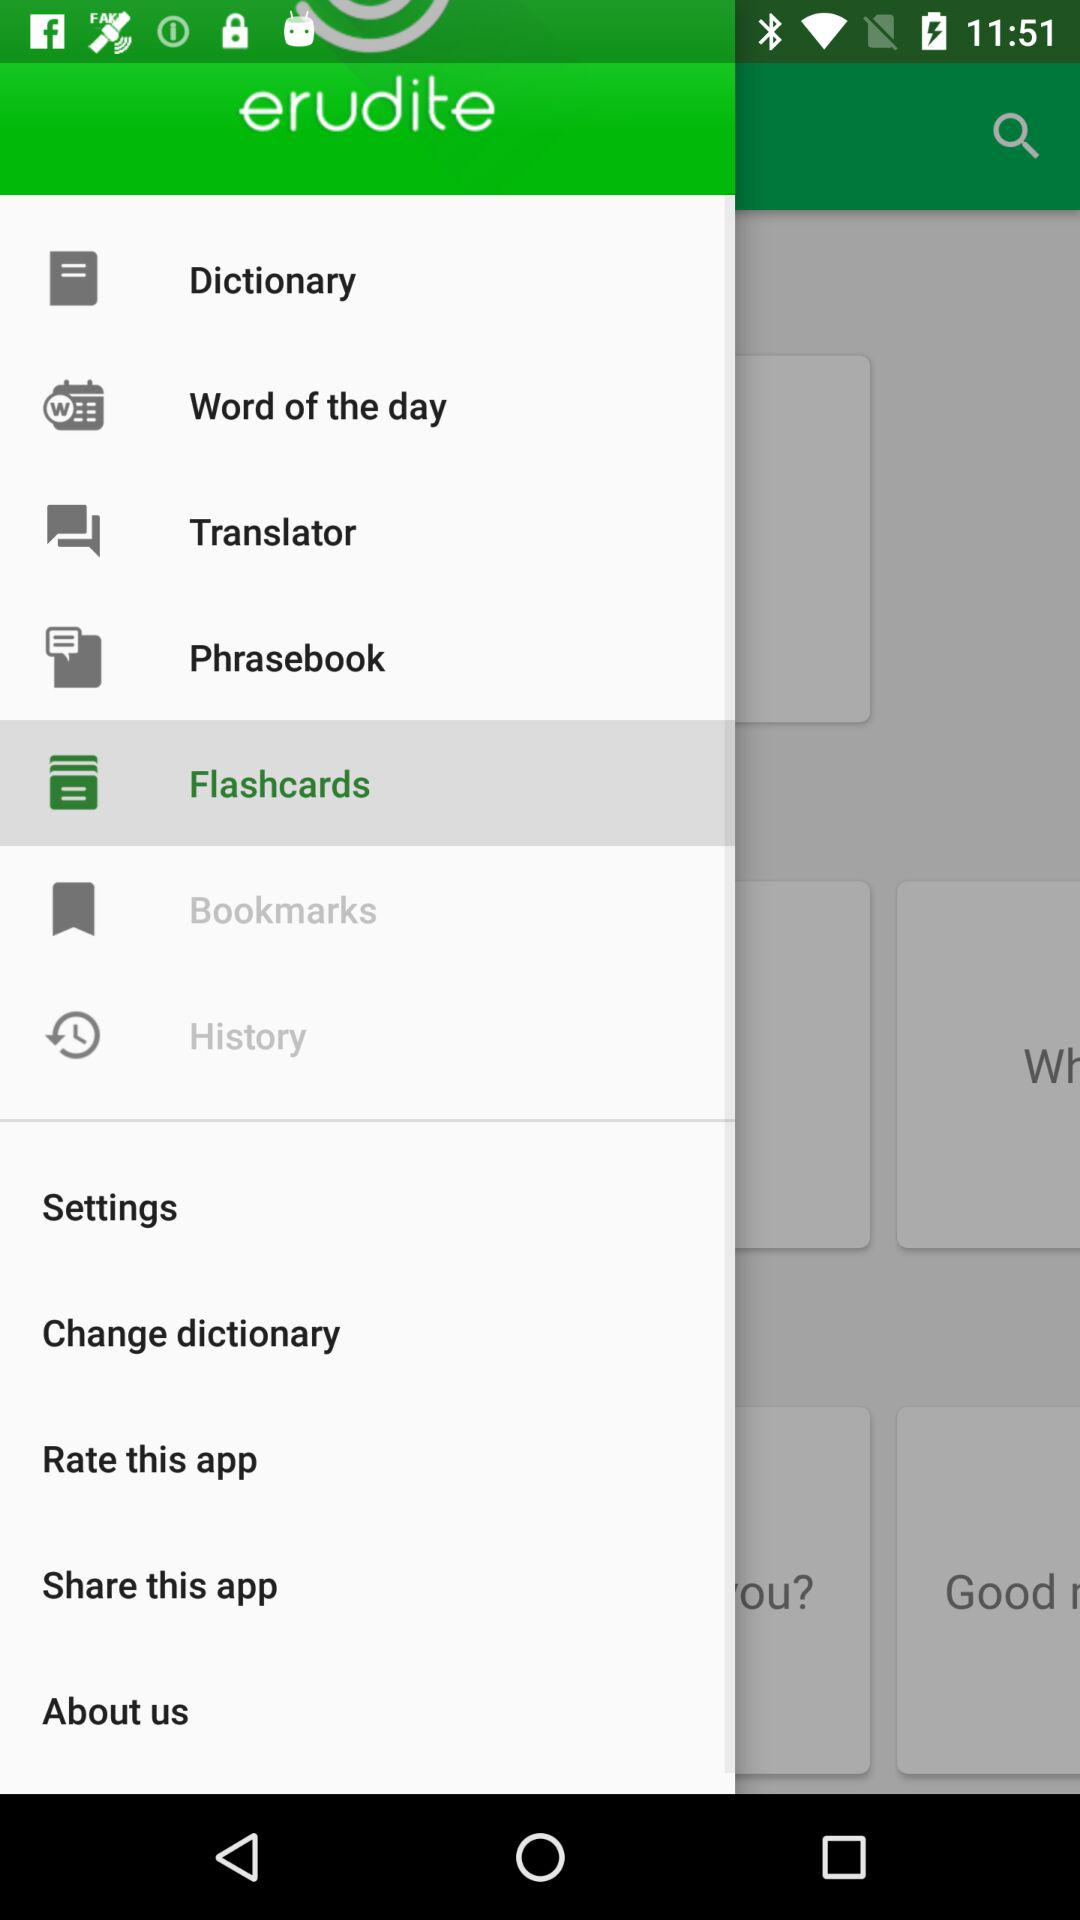What is the application name? The application name is "erudite". 